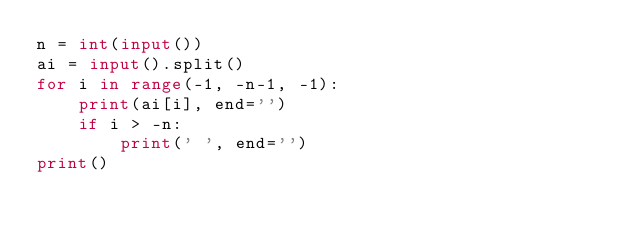Convert code to text. <code><loc_0><loc_0><loc_500><loc_500><_Python_>n = int(input())
ai = input().split()
for i in range(-1, -n-1, -1):
    print(ai[i], end='')
    if i > -n:
        print(' ', end='')
print()

</code> 